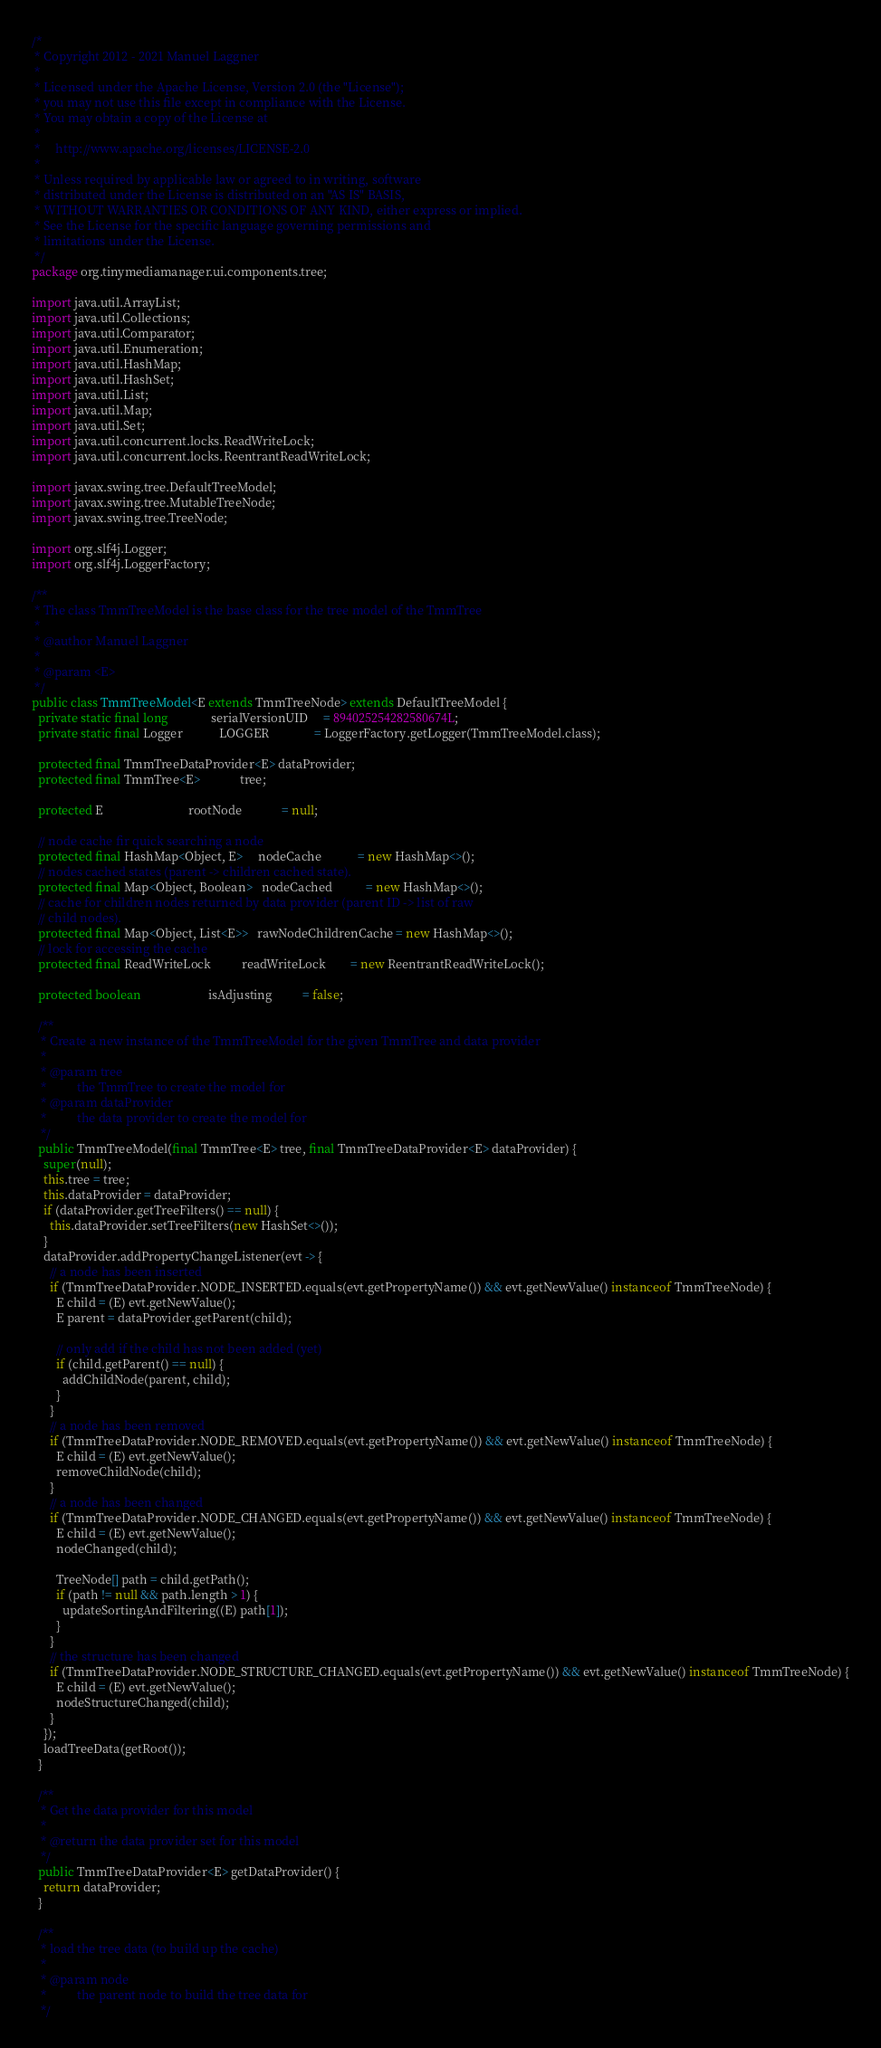Convert code to text. <code><loc_0><loc_0><loc_500><loc_500><_Java_>/*
 * Copyright 2012 - 2021 Manuel Laggner
 *
 * Licensed under the Apache License, Version 2.0 (the "License");
 * you may not use this file except in compliance with the License.
 * You may obtain a copy of the License at
 *
 *     http://www.apache.org/licenses/LICENSE-2.0
 *
 * Unless required by applicable law or agreed to in writing, software
 * distributed under the License is distributed on an "AS IS" BASIS,
 * WITHOUT WARRANTIES OR CONDITIONS OF ANY KIND, either express or implied.
 * See the License for the specific language governing permissions and
 * limitations under the License.
 */
package org.tinymediamanager.ui.components.tree;

import java.util.ArrayList;
import java.util.Collections;
import java.util.Comparator;
import java.util.Enumeration;
import java.util.HashMap;
import java.util.HashSet;
import java.util.List;
import java.util.Map;
import java.util.Set;
import java.util.concurrent.locks.ReadWriteLock;
import java.util.concurrent.locks.ReentrantReadWriteLock;

import javax.swing.tree.DefaultTreeModel;
import javax.swing.tree.MutableTreeNode;
import javax.swing.tree.TreeNode;

import org.slf4j.Logger;
import org.slf4j.LoggerFactory;

/**
 * The class TmmTreeModel is the base class for the tree model of the TmmTree
 * 
 * @author Manuel Laggner
 *
 * @param <E>
 */
public class TmmTreeModel<E extends TmmTreeNode> extends DefaultTreeModel {
  private static final long              serialVersionUID     = 894025254282580674L;
  private static final Logger            LOGGER               = LoggerFactory.getLogger(TmmTreeModel.class);

  protected final TmmTreeDataProvider<E> dataProvider;
  protected final TmmTree<E>             tree;

  protected E                            rootNode             = null;

  // node cache fir quick searching a node
  protected final HashMap<Object, E>     nodeCache            = new HashMap<>();
  // nodes cached states (parent -> children cached state).
  protected final Map<Object, Boolean>   nodeCached           = new HashMap<>();
  // cache for children nodes returned by data provider (parent ID -> list of raw
  // child nodes).
  protected final Map<Object, List<E>>   rawNodeChildrenCache = new HashMap<>();
  // lock for accessing the cache
  protected final ReadWriteLock          readWriteLock        = new ReentrantReadWriteLock();

  protected boolean                      isAdjusting          = false;

  /**
   * Create a new instance of the TmmTreeModel for the given TmmTree and data provider
   * 
   * @param tree
   *          the TmmTree to create the model for
   * @param dataProvider
   *          the data provider to create the model for
   */
  public TmmTreeModel(final TmmTree<E> tree, final TmmTreeDataProvider<E> dataProvider) {
    super(null);
    this.tree = tree;
    this.dataProvider = dataProvider;
    if (dataProvider.getTreeFilters() == null) {
      this.dataProvider.setTreeFilters(new HashSet<>());
    }
    dataProvider.addPropertyChangeListener(evt -> {
      // a node has been inserted
      if (TmmTreeDataProvider.NODE_INSERTED.equals(evt.getPropertyName()) && evt.getNewValue() instanceof TmmTreeNode) {
        E child = (E) evt.getNewValue();
        E parent = dataProvider.getParent(child);

        // only add if the child has not been added (yet)
        if (child.getParent() == null) {
          addChildNode(parent, child);
        }
      }
      // a node has been removed
      if (TmmTreeDataProvider.NODE_REMOVED.equals(evt.getPropertyName()) && evt.getNewValue() instanceof TmmTreeNode) {
        E child = (E) evt.getNewValue();
        removeChildNode(child);
      }
      // a node has been changed
      if (TmmTreeDataProvider.NODE_CHANGED.equals(evt.getPropertyName()) && evt.getNewValue() instanceof TmmTreeNode) {
        E child = (E) evt.getNewValue();
        nodeChanged(child);

        TreeNode[] path = child.getPath();
        if (path != null && path.length > 1) {
          updateSortingAndFiltering((E) path[1]);
        }
      }
      // the structure has been changed
      if (TmmTreeDataProvider.NODE_STRUCTURE_CHANGED.equals(evt.getPropertyName()) && evt.getNewValue() instanceof TmmTreeNode) {
        E child = (E) evt.getNewValue();
        nodeStructureChanged(child);
      }
    });
    loadTreeData(getRoot());
  }

  /**
   * Get the data provider for this model
   *
   * @return the data provider set for this model
   */
  public TmmTreeDataProvider<E> getDataProvider() {
    return dataProvider;
  }

  /**
   * load the tree data (to build up the cache)
   * 
   * @param node
   *          the parent node to build the tree data for
   */</code> 